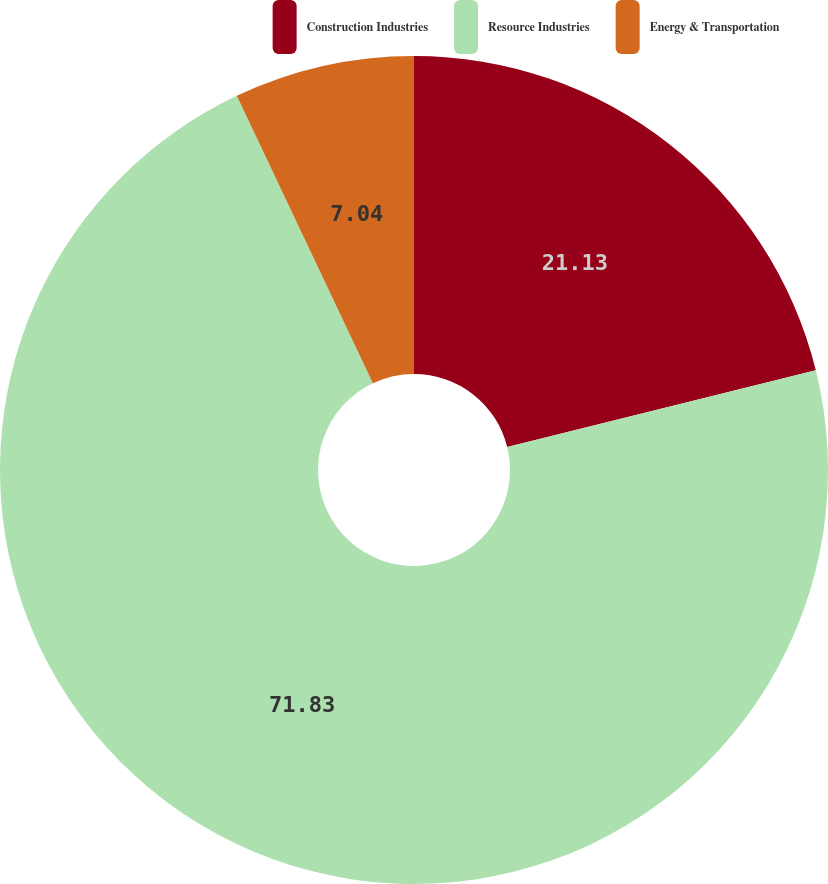Convert chart to OTSL. <chart><loc_0><loc_0><loc_500><loc_500><pie_chart><fcel>Construction Industries<fcel>Resource Industries<fcel>Energy & Transportation<nl><fcel>21.13%<fcel>71.83%<fcel>7.04%<nl></chart> 